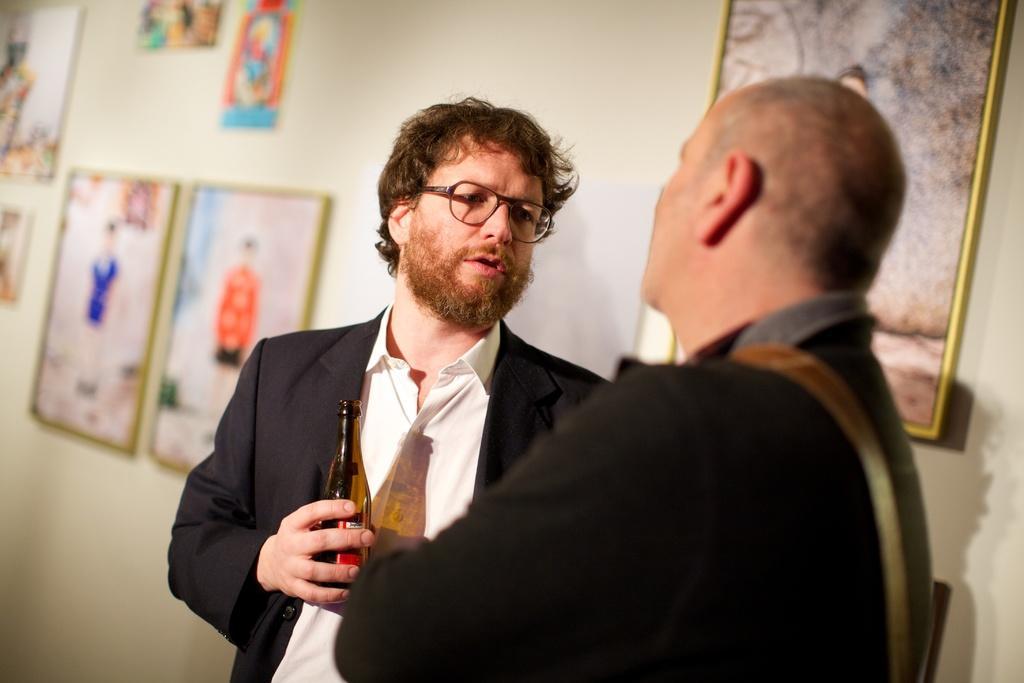Can you describe this image briefly? In this image there are 2 persons standing ,and in back ground there is a frame attached to a wall. 